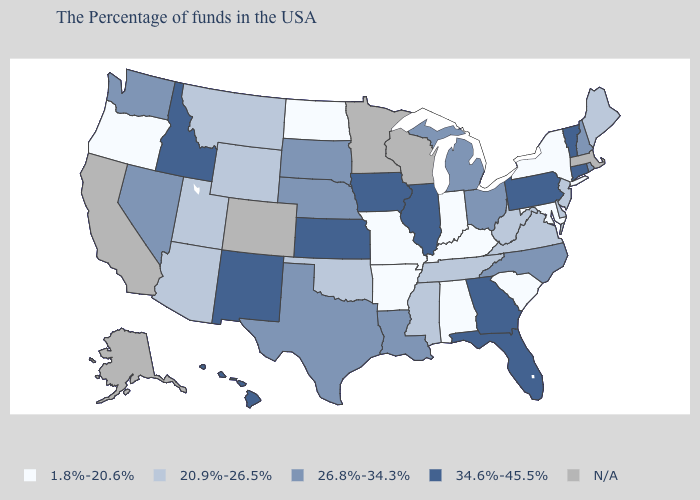Is the legend a continuous bar?
Keep it brief. No. Name the states that have a value in the range 26.8%-34.3%?
Give a very brief answer. Rhode Island, New Hampshire, North Carolina, Ohio, Michigan, Louisiana, Nebraska, Texas, South Dakota, Nevada, Washington. What is the value of Wyoming?
Keep it brief. 20.9%-26.5%. Is the legend a continuous bar?
Answer briefly. No. What is the value of South Carolina?
Quick response, please. 1.8%-20.6%. What is the value of Nevada?
Keep it brief. 26.8%-34.3%. What is the lowest value in the South?
Answer briefly. 1.8%-20.6%. Among the states that border Missouri , which have the lowest value?
Quick response, please. Kentucky, Arkansas. Name the states that have a value in the range 26.8%-34.3%?
Keep it brief. Rhode Island, New Hampshire, North Carolina, Ohio, Michigan, Louisiana, Nebraska, Texas, South Dakota, Nevada, Washington. What is the value of Colorado?
Quick response, please. N/A. What is the value of Nevada?
Short answer required. 26.8%-34.3%. What is the value of Virginia?
Give a very brief answer. 20.9%-26.5%. What is the lowest value in the MidWest?
Short answer required. 1.8%-20.6%. What is the value of Maine?
Quick response, please. 20.9%-26.5%. What is the value of Rhode Island?
Concise answer only. 26.8%-34.3%. 